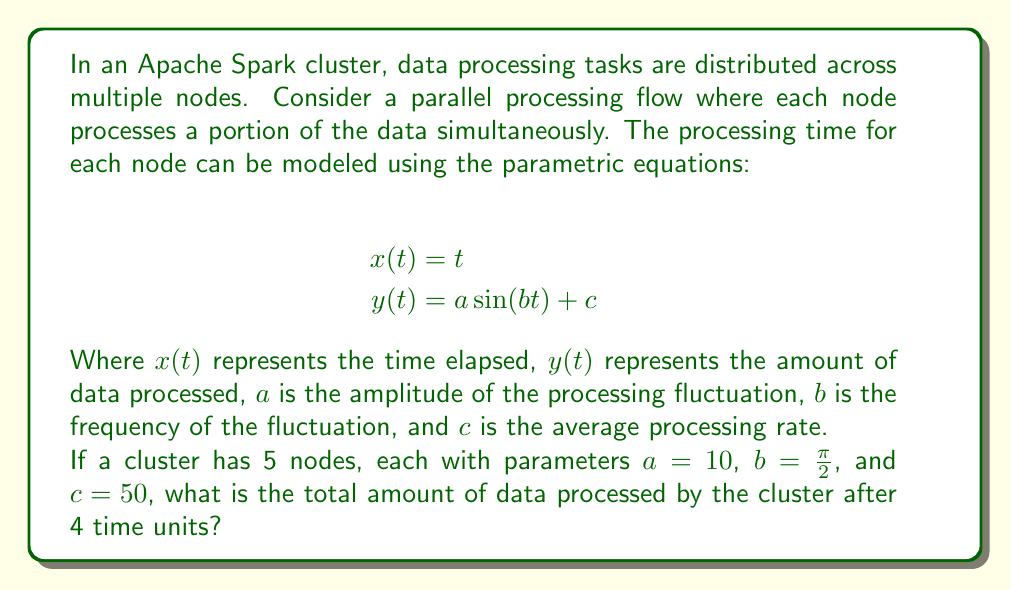Can you solve this math problem? To solve this problem, we need to follow these steps:

1. Understand the parametric equations:
   $x(t) = t$ represents time
   $y(t) = a \sin(bt) + c$ represents the amount of data processed

2. Substitute the given values:
   $a = 10$
   $b = \frac{\pi}{2}$
   $c = 50$
   $t = 4$ (time units)

3. Calculate the amount of data processed by one node:
   $$y(4) = 10 \sin(\frac{\pi}{2} \cdot 4) + 50$$
   $$y(4) = 10 \sin(2\pi) + 50$$
   $$y(4) = 10 \cdot 0 + 50 = 50$$

4. Since there are 5 nodes processing data in parallel, multiply the result by 5:
   Total data processed = $50 \cdot 5 = 250$

The total amount of data processed by the cluster after 4 time units is 250 units.

Note: In this model, the sine function represents fluctuations in processing speed, but after exactly 4 time units (which is a multiple of the period of the sine function), the fluctuation component becomes zero, resulting in only the average processing rate ($c$) contributing to the final result.
Answer: 250 units of data 